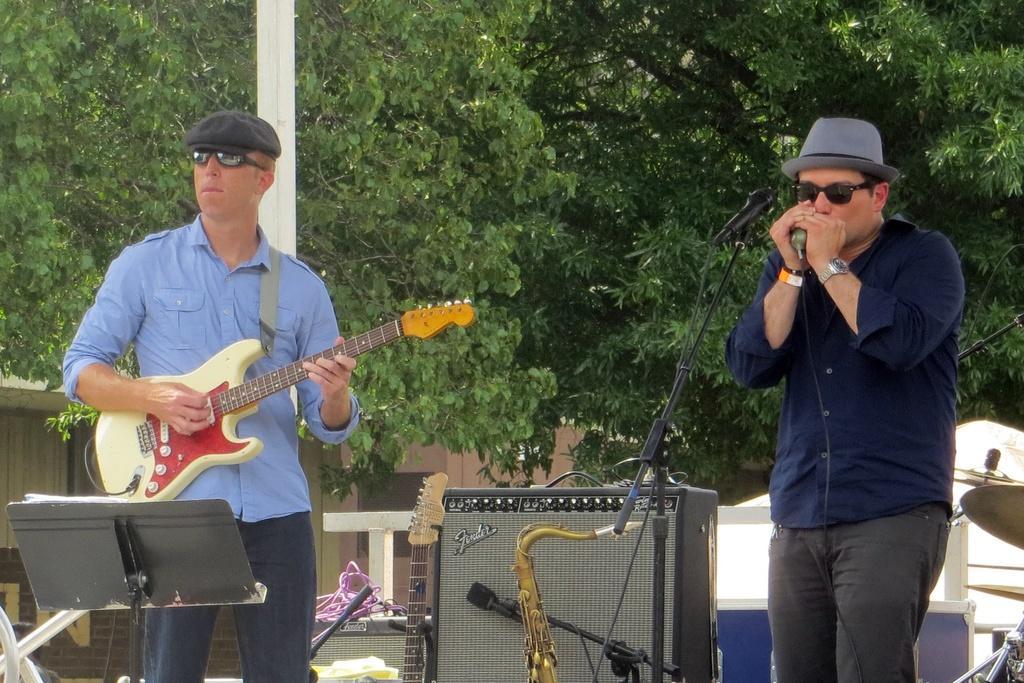Could you give a brief overview of what you see in this image? The person in the left is playing guitar and the person in the right is singing in front of a mic and there are some musical instruments behind them. In background there are trees. 